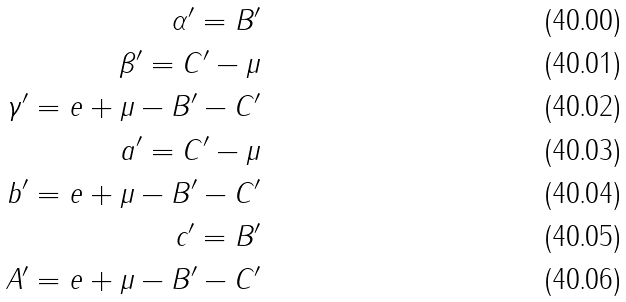Convert formula to latex. <formula><loc_0><loc_0><loc_500><loc_500>\alpha ^ { \prime } = B ^ { \prime } \\ \beta ^ { \prime } = C ^ { \prime } - \mu \\ \gamma ^ { \prime } = e + \mu - B ^ { \prime } - C ^ { \prime } \\ a ^ { \prime } = C ^ { \prime } - \mu \\ b ^ { \prime } = e + \mu - B ^ { \prime } - C ^ { \prime } \\ c ^ { \prime } = B ^ { \prime } \\ A ^ { \prime } = e + \mu - B ^ { \prime } - C ^ { \prime }</formula> 